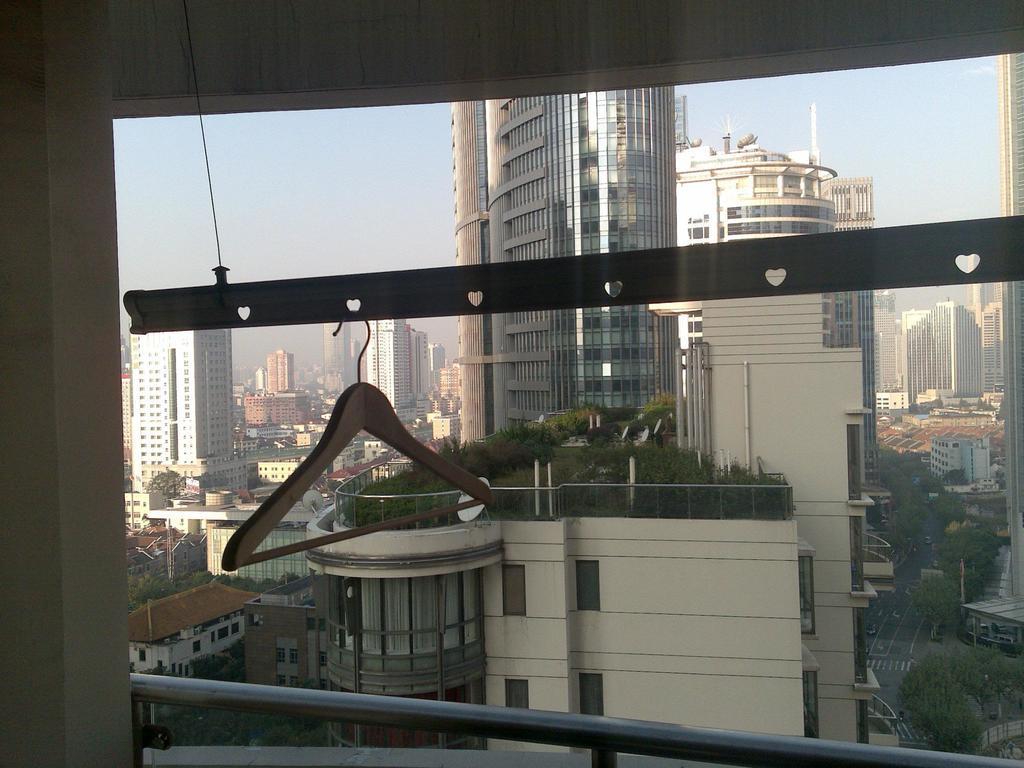Can you describe this image briefly? In the picture we can see from the window and to it we can see a hanger and from the window we can see many buildings, tower buildings with many floors and windows to it and we can also see some roads and trees and we can see a sky. 